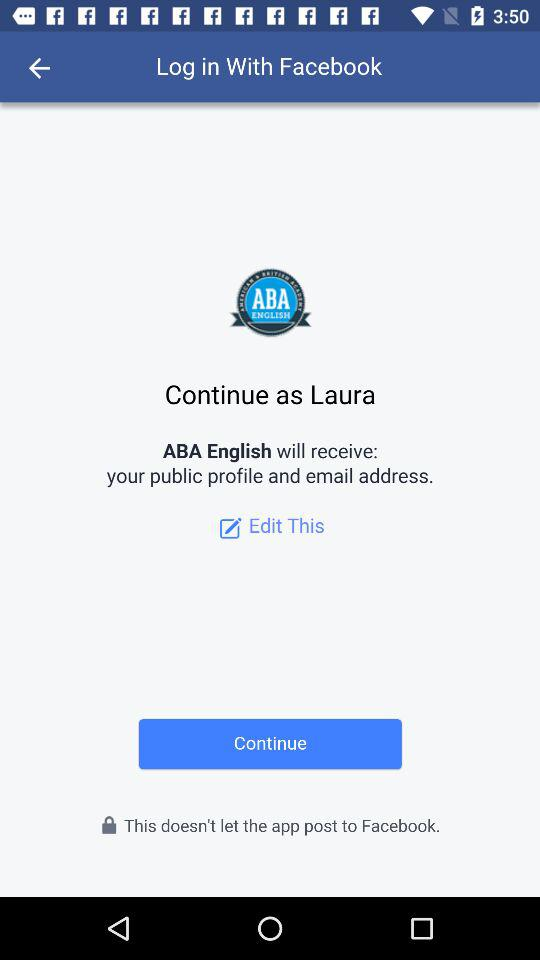What application will receive your public profile and email address? The application "ABA English" will receive your public profile and email address. 